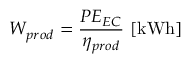<formula> <loc_0><loc_0><loc_500><loc_500>W _ { p r o d } = \frac { P E _ { E C } } { \eta _ { p r o d } } \ [ k W h ]</formula> 